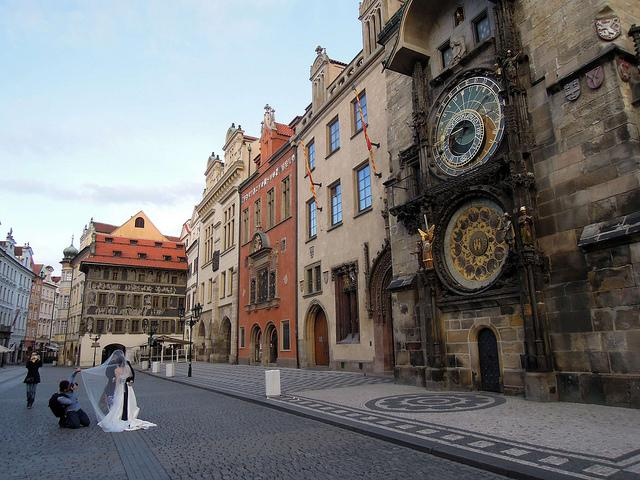What is the woman wearing?

Choices:
A) backpack
B) wedding dress
C) bicycle helmet
D) crown wedding dress 